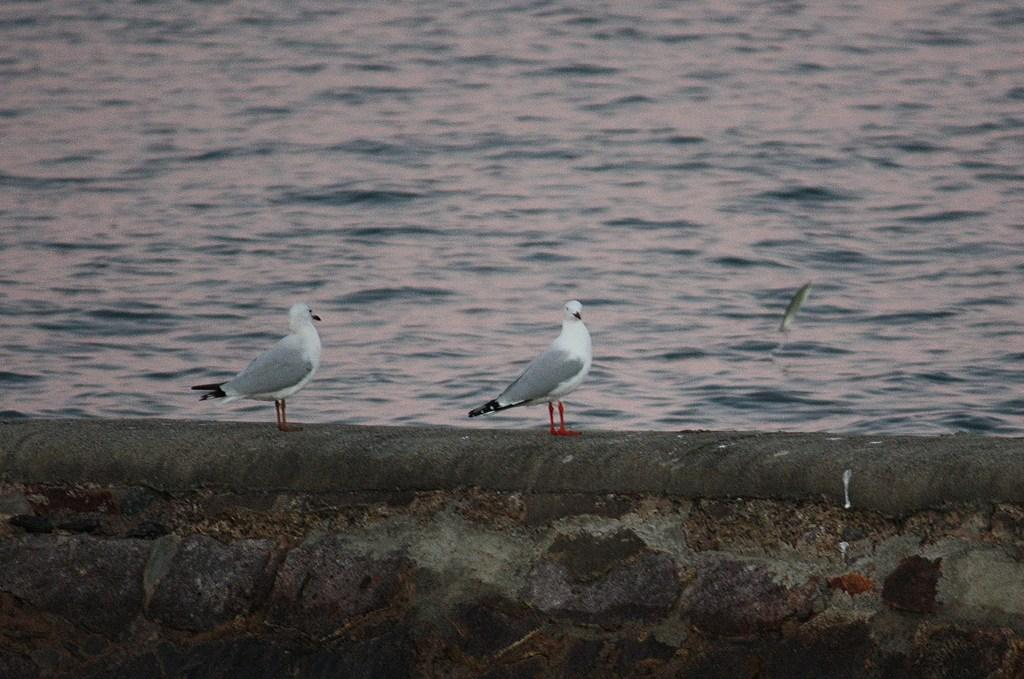How many birds are present in the image? There are two birds in the image. Where are the birds located? The birds are standing on a wall. What can be seen in the background of the image? There is water visible in the background of the image. What type of veil can be seen on the birds in the image? There is no veil present on the birds in the image. Can you compare the size of the two birds in the image? The provided facts do not include information about the size of the birds, so it is not possible to make a comparison. 